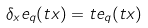Convert formula to latex. <formula><loc_0><loc_0><loc_500><loc_500>\delta _ { x } e _ { q } ( t x ) = t e _ { q } ( t x )</formula> 